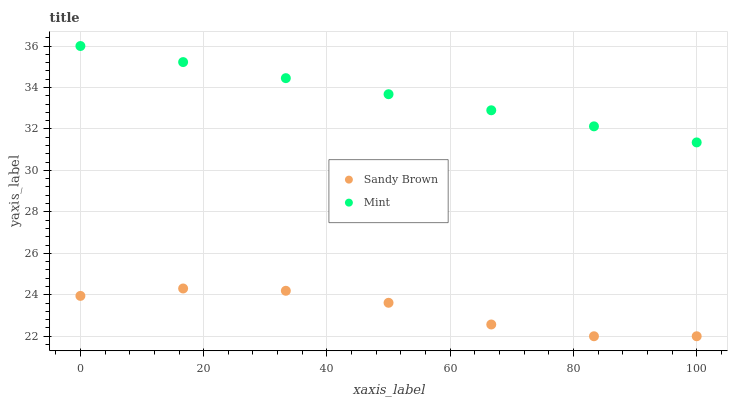Does Sandy Brown have the minimum area under the curve?
Answer yes or no. Yes. Does Mint have the maximum area under the curve?
Answer yes or no. Yes. Does Sandy Brown have the maximum area under the curve?
Answer yes or no. No. Is Mint the smoothest?
Answer yes or no. Yes. Is Sandy Brown the roughest?
Answer yes or no. Yes. Is Sandy Brown the smoothest?
Answer yes or no. No. Does Sandy Brown have the lowest value?
Answer yes or no. Yes. Does Mint have the highest value?
Answer yes or no. Yes. Does Sandy Brown have the highest value?
Answer yes or no. No. Is Sandy Brown less than Mint?
Answer yes or no. Yes. Is Mint greater than Sandy Brown?
Answer yes or no. Yes. Does Sandy Brown intersect Mint?
Answer yes or no. No. 